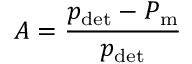Convert formula to latex. <formula><loc_0><loc_0><loc_500><loc_500>A = \frac { p _ { d e t } - P _ { m } } { p _ { d e t } }</formula> 